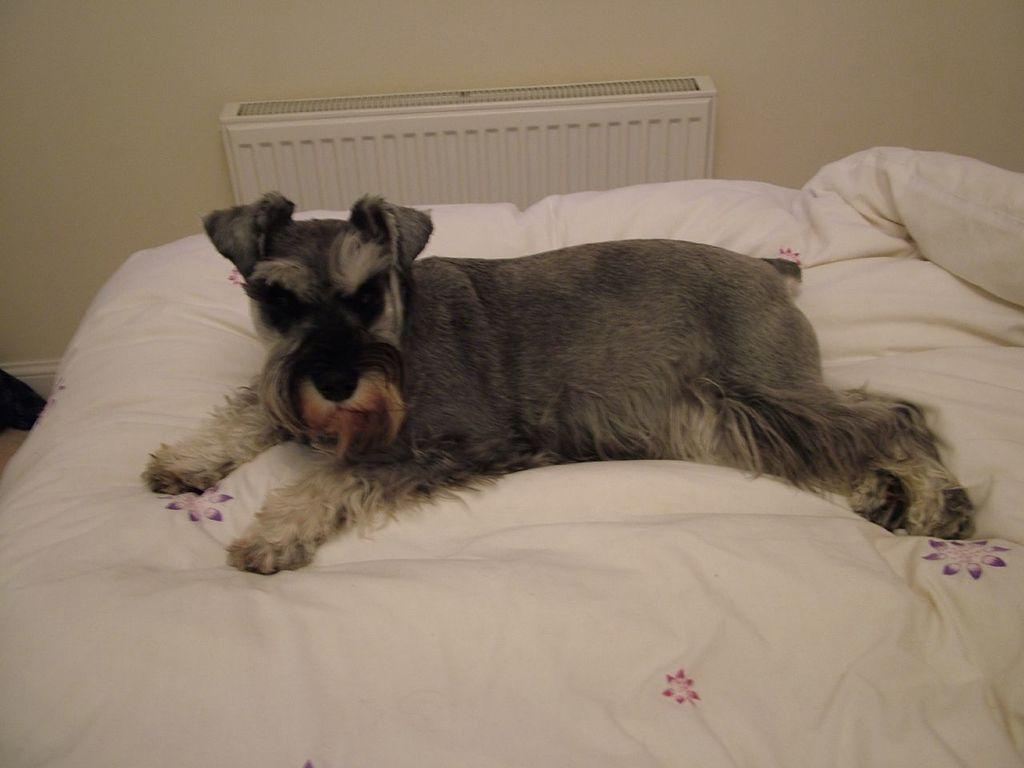What type of furniture is present in the image? There is a bed in the image. What is lying on the bed in the image? There is a dog lying on the bed. How many trees can be seen in the image? There are no trees present in the image; it features a bed with a dog lying on it. What type of balloon is floating above the bed in the image? There is no balloon present in the image. Can you see a knife on the bed in the image? There is no knife present on the bed in the image. 